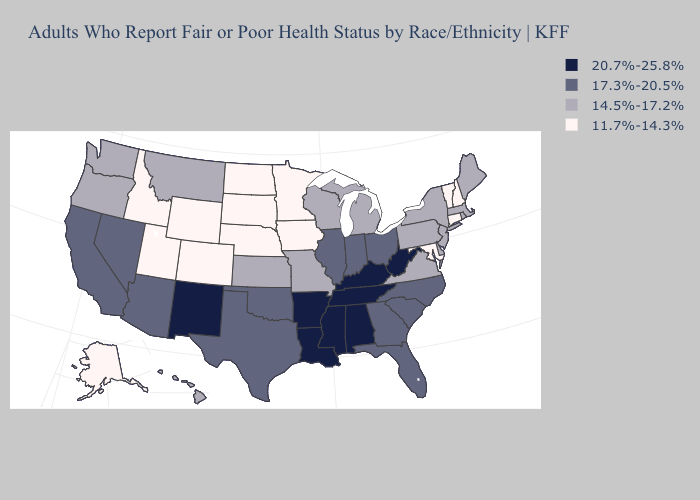Which states have the lowest value in the West?
Keep it brief. Alaska, Colorado, Idaho, Utah, Wyoming. What is the lowest value in states that border Maryland?
Quick response, please. 14.5%-17.2%. Does Illinois have the highest value in the MidWest?
Short answer required. Yes. What is the value of Tennessee?
Concise answer only. 20.7%-25.8%. What is the highest value in the Northeast ?
Keep it brief. 14.5%-17.2%. What is the value of Texas?
Concise answer only. 17.3%-20.5%. Among the states that border South Dakota , which have the highest value?
Be succinct. Montana. Is the legend a continuous bar?
Quick response, please. No. What is the highest value in states that border Utah?
Concise answer only. 20.7%-25.8%. What is the highest value in states that border Arizona?
Write a very short answer. 20.7%-25.8%. Name the states that have a value in the range 20.7%-25.8%?
Write a very short answer. Alabama, Arkansas, Kentucky, Louisiana, Mississippi, New Mexico, Tennessee, West Virginia. What is the value of Rhode Island?
Short answer required. 14.5%-17.2%. What is the lowest value in the USA?
Concise answer only. 11.7%-14.3%. Does the first symbol in the legend represent the smallest category?
Concise answer only. No. Name the states that have a value in the range 20.7%-25.8%?
Give a very brief answer. Alabama, Arkansas, Kentucky, Louisiana, Mississippi, New Mexico, Tennessee, West Virginia. 